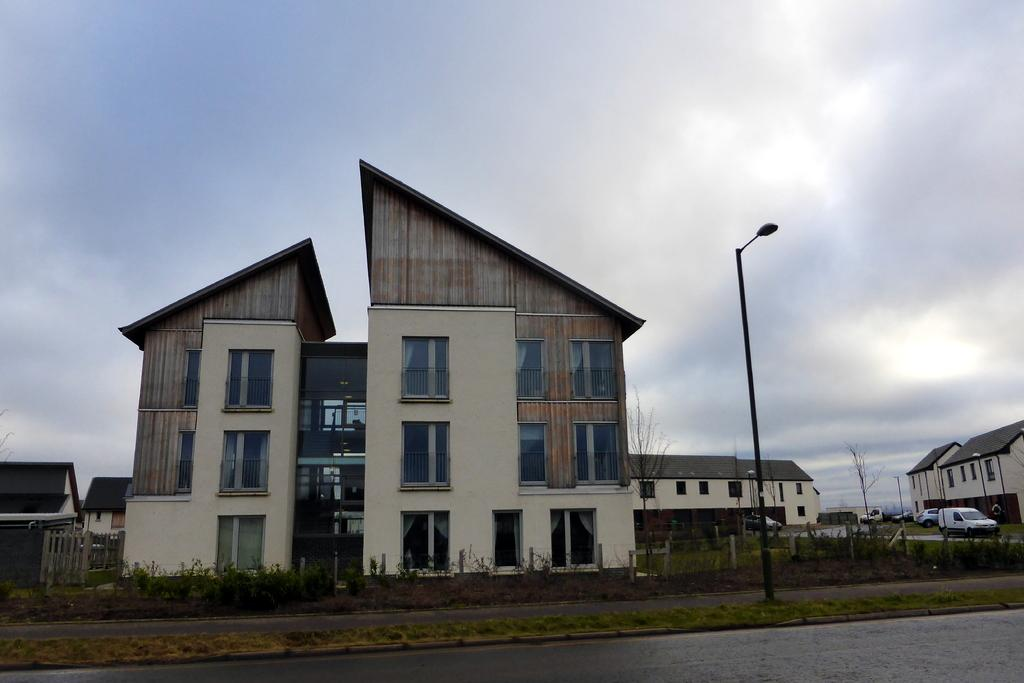What can be seen in the foreground of the image? In the foreground of the image, there is a road, grass, and a pole. What is visible in the background of the image? In the background of the image, there are buildings, cars, trees, and clouds. Can you describe the road in the foreground? The road in the foreground appears to be a paved road with a yellow line down the middle. What type of vegetation can be seen in the background of the image? Trees can be seen in the background of the image. What type of mine can be seen in the image? There is no mine present in the image. How can we help the people in the image? There are no people present in the image, so we cannot help them. 